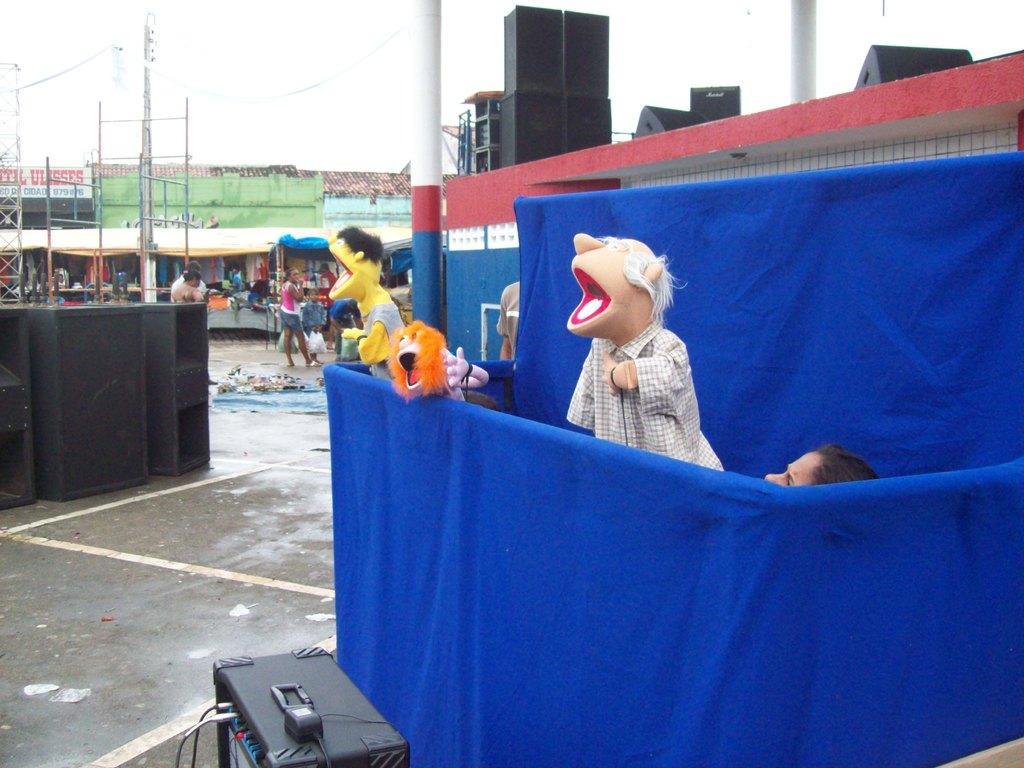How would you summarize this image in a sentence or two? In the picture we can see a play of the dolls conducted by persons behind the curtain and behind it, we can see a stage with some music boxes on it and in the background, we can see some stalls and some people are standing near it and behind it we can see the sky. 